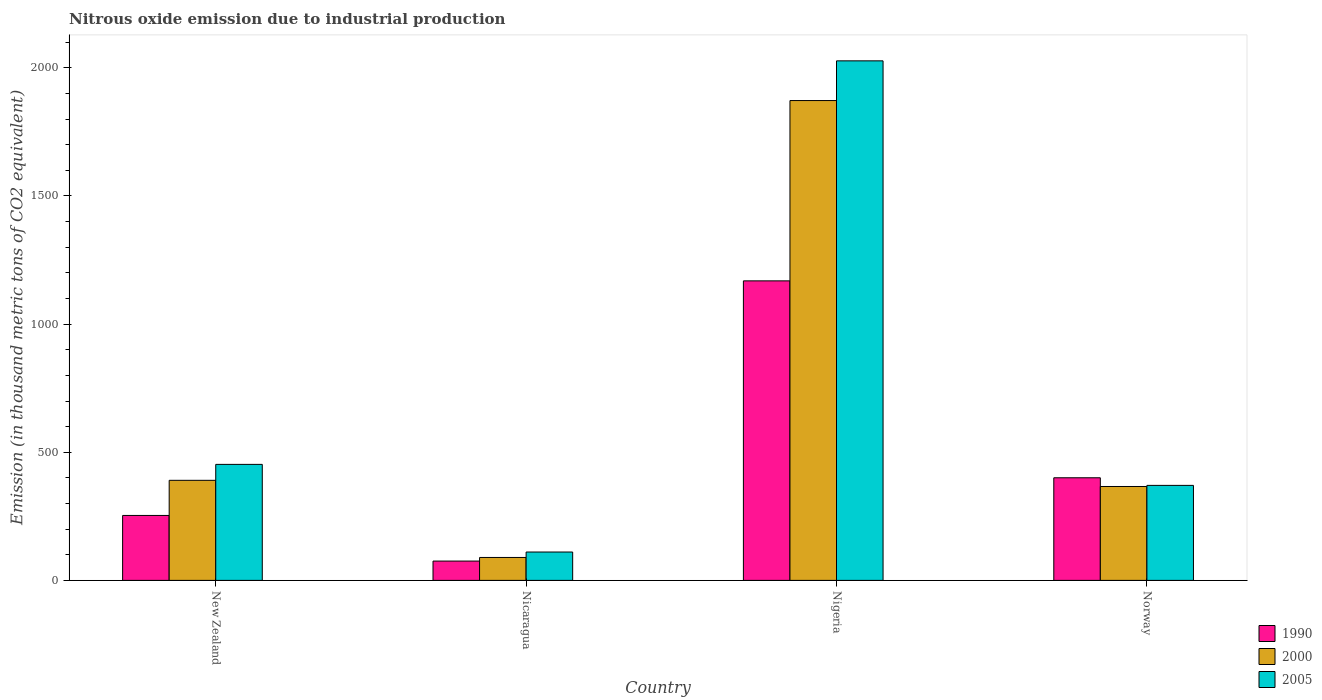Are the number of bars per tick equal to the number of legend labels?
Ensure brevity in your answer.  Yes. Are the number of bars on each tick of the X-axis equal?
Keep it short and to the point. Yes. How many bars are there on the 1st tick from the left?
Provide a short and direct response. 3. How many bars are there on the 3rd tick from the right?
Your response must be concise. 3. What is the label of the 3rd group of bars from the left?
Make the answer very short. Nigeria. In how many cases, is the number of bars for a given country not equal to the number of legend labels?
Your answer should be compact. 0. What is the amount of nitrous oxide emitted in 2005 in New Zealand?
Provide a succinct answer. 452.7. Across all countries, what is the maximum amount of nitrous oxide emitted in 2005?
Give a very brief answer. 2027.3. Across all countries, what is the minimum amount of nitrous oxide emitted in 2005?
Provide a short and direct response. 110.7. In which country was the amount of nitrous oxide emitted in 1990 maximum?
Your answer should be compact. Nigeria. In which country was the amount of nitrous oxide emitted in 1990 minimum?
Provide a succinct answer. Nicaragua. What is the total amount of nitrous oxide emitted in 2000 in the graph?
Give a very brief answer. 2718.8. What is the difference between the amount of nitrous oxide emitted in 2005 in Nicaragua and that in Norway?
Your response must be concise. -260. What is the difference between the amount of nitrous oxide emitted in 2005 in Nigeria and the amount of nitrous oxide emitted in 2000 in Norway?
Ensure brevity in your answer.  1660.9. What is the average amount of nitrous oxide emitted in 2000 per country?
Make the answer very short. 679.7. What is the difference between the amount of nitrous oxide emitted of/in 2005 and amount of nitrous oxide emitted of/in 1990 in New Zealand?
Give a very brief answer. 199.3. What is the ratio of the amount of nitrous oxide emitted in 1990 in Nicaragua to that in Norway?
Your answer should be very brief. 0.19. Is the amount of nitrous oxide emitted in 2000 in Nicaragua less than that in Nigeria?
Keep it short and to the point. Yes. What is the difference between the highest and the second highest amount of nitrous oxide emitted in 1990?
Make the answer very short. 915.4. What is the difference between the highest and the lowest amount of nitrous oxide emitted in 1990?
Make the answer very short. 1093.4. In how many countries, is the amount of nitrous oxide emitted in 2000 greater than the average amount of nitrous oxide emitted in 2000 taken over all countries?
Give a very brief answer. 1. Is the sum of the amount of nitrous oxide emitted in 2005 in Nicaragua and Norway greater than the maximum amount of nitrous oxide emitted in 1990 across all countries?
Offer a very short reply. No. What does the 1st bar from the left in Nigeria represents?
Provide a succinct answer. 1990. Is it the case that in every country, the sum of the amount of nitrous oxide emitted in 2005 and amount of nitrous oxide emitted in 2000 is greater than the amount of nitrous oxide emitted in 1990?
Offer a very short reply. Yes. How many bars are there?
Make the answer very short. 12. Are all the bars in the graph horizontal?
Your answer should be compact. No. What is the difference between two consecutive major ticks on the Y-axis?
Offer a very short reply. 500. Does the graph contain grids?
Make the answer very short. No. Where does the legend appear in the graph?
Ensure brevity in your answer.  Bottom right. How many legend labels are there?
Your answer should be compact. 3. How are the legend labels stacked?
Your response must be concise. Vertical. What is the title of the graph?
Your answer should be very brief. Nitrous oxide emission due to industrial production. What is the label or title of the Y-axis?
Offer a very short reply. Emission (in thousand metric tons of CO2 equivalent). What is the Emission (in thousand metric tons of CO2 equivalent) of 1990 in New Zealand?
Ensure brevity in your answer.  253.4. What is the Emission (in thousand metric tons of CO2 equivalent) in 2000 in New Zealand?
Your answer should be very brief. 390.5. What is the Emission (in thousand metric tons of CO2 equivalent) in 2005 in New Zealand?
Give a very brief answer. 452.7. What is the Emission (in thousand metric tons of CO2 equivalent) of 1990 in Nicaragua?
Make the answer very short. 75.4. What is the Emission (in thousand metric tons of CO2 equivalent) in 2000 in Nicaragua?
Your answer should be very brief. 89.5. What is the Emission (in thousand metric tons of CO2 equivalent) of 2005 in Nicaragua?
Give a very brief answer. 110.7. What is the Emission (in thousand metric tons of CO2 equivalent) of 1990 in Nigeria?
Offer a very short reply. 1168.8. What is the Emission (in thousand metric tons of CO2 equivalent) of 2000 in Nigeria?
Offer a terse response. 1872.4. What is the Emission (in thousand metric tons of CO2 equivalent) in 2005 in Nigeria?
Make the answer very short. 2027.3. What is the Emission (in thousand metric tons of CO2 equivalent) of 1990 in Norway?
Give a very brief answer. 400.4. What is the Emission (in thousand metric tons of CO2 equivalent) in 2000 in Norway?
Keep it short and to the point. 366.4. What is the Emission (in thousand metric tons of CO2 equivalent) of 2005 in Norway?
Provide a short and direct response. 370.7. Across all countries, what is the maximum Emission (in thousand metric tons of CO2 equivalent) of 1990?
Ensure brevity in your answer.  1168.8. Across all countries, what is the maximum Emission (in thousand metric tons of CO2 equivalent) of 2000?
Your answer should be compact. 1872.4. Across all countries, what is the maximum Emission (in thousand metric tons of CO2 equivalent) in 2005?
Your response must be concise. 2027.3. Across all countries, what is the minimum Emission (in thousand metric tons of CO2 equivalent) in 1990?
Ensure brevity in your answer.  75.4. Across all countries, what is the minimum Emission (in thousand metric tons of CO2 equivalent) of 2000?
Offer a very short reply. 89.5. Across all countries, what is the minimum Emission (in thousand metric tons of CO2 equivalent) in 2005?
Keep it short and to the point. 110.7. What is the total Emission (in thousand metric tons of CO2 equivalent) of 1990 in the graph?
Your answer should be compact. 1898. What is the total Emission (in thousand metric tons of CO2 equivalent) of 2000 in the graph?
Offer a very short reply. 2718.8. What is the total Emission (in thousand metric tons of CO2 equivalent) in 2005 in the graph?
Keep it short and to the point. 2961.4. What is the difference between the Emission (in thousand metric tons of CO2 equivalent) of 1990 in New Zealand and that in Nicaragua?
Offer a very short reply. 178. What is the difference between the Emission (in thousand metric tons of CO2 equivalent) of 2000 in New Zealand and that in Nicaragua?
Your answer should be compact. 301. What is the difference between the Emission (in thousand metric tons of CO2 equivalent) in 2005 in New Zealand and that in Nicaragua?
Make the answer very short. 342. What is the difference between the Emission (in thousand metric tons of CO2 equivalent) of 1990 in New Zealand and that in Nigeria?
Offer a very short reply. -915.4. What is the difference between the Emission (in thousand metric tons of CO2 equivalent) of 2000 in New Zealand and that in Nigeria?
Your answer should be compact. -1481.9. What is the difference between the Emission (in thousand metric tons of CO2 equivalent) of 2005 in New Zealand and that in Nigeria?
Your answer should be very brief. -1574.6. What is the difference between the Emission (in thousand metric tons of CO2 equivalent) of 1990 in New Zealand and that in Norway?
Your answer should be compact. -147. What is the difference between the Emission (in thousand metric tons of CO2 equivalent) of 2000 in New Zealand and that in Norway?
Your response must be concise. 24.1. What is the difference between the Emission (in thousand metric tons of CO2 equivalent) of 2005 in New Zealand and that in Norway?
Provide a short and direct response. 82. What is the difference between the Emission (in thousand metric tons of CO2 equivalent) of 1990 in Nicaragua and that in Nigeria?
Give a very brief answer. -1093.4. What is the difference between the Emission (in thousand metric tons of CO2 equivalent) of 2000 in Nicaragua and that in Nigeria?
Provide a succinct answer. -1782.9. What is the difference between the Emission (in thousand metric tons of CO2 equivalent) of 2005 in Nicaragua and that in Nigeria?
Give a very brief answer. -1916.6. What is the difference between the Emission (in thousand metric tons of CO2 equivalent) in 1990 in Nicaragua and that in Norway?
Your answer should be very brief. -325. What is the difference between the Emission (in thousand metric tons of CO2 equivalent) of 2000 in Nicaragua and that in Norway?
Ensure brevity in your answer.  -276.9. What is the difference between the Emission (in thousand metric tons of CO2 equivalent) of 2005 in Nicaragua and that in Norway?
Provide a succinct answer. -260. What is the difference between the Emission (in thousand metric tons of CO2 equivalent) in 1990 in Nigeria and that in Norway?
Ensure brevity in your answer.  768.4. What is the difference between the Emission (in thousand metric tons of CO2 equivalent) in 2000 in Nigeria and that in Norway?
Your response must be concise. 1506. What is the difference between the Emission (in thousand metric tons of CO2 equivalent) of 2005 in Nigeria and that in Norway?
Provide a short and direct response. 1656.6. What is the difference between the Emission (in thousand metric tons of CO2 equivalent) of 1990 in New Zealand and the Emission (in thousand metric tons of CO2 equivalent) of 2000 in Nicaragua?
Provide a succinct answer. 163.9. What is the difference between the Emission (in thousand metric tons of CO2 equivalent) in 1990 in New Zealand and the Emission (in thousand metric tons of CO2 equivalent) in 2005 in Nicaragua?
Make the answer very short. 142.7. What is the difference between the Emission (in thousand metric tons of CO2 equivalent) in 2000 in New Zealand and the Emission (in thousand metric tons of CO2 equivalent) in 2005 in Nicaragua?
Keep it short and to the point. 279.8. What is the difference between the Emission (in thousand metric tons of CO2 equivalent) in 1990 in New Zealand and the Emission (in thousand metric tons of CO2 equivalent) in 2000 in Nigeria?
Keep it short and to the point. -1619. What is the difference between the Emission (in thousand metric tons of CO2 equivalent) of 1990 in New Zealand and the Emission (in thousand metric tons of CO2 equivalent) of 2005 in Nigeria?
Ensure brevity in your answer.  -1773.9. What is the difference between the Emission (in thousand metric tons of CO2 equivalent) of 2000 in New Zealand and the Emission (in thousand metric tons of CO2 equivalent) of 2005 in Nigeria?
Offer a terse response. -1636.8. What is the difference between the Emission (in thousand metric tons of CO2 equivalent) of 1990 in New Zealand and the Emission (in thousand metric tons of CO2 equivalent) of 2000 in Norway?
Offer a terse response. -113. What is the difference between the Emission (in thousand metric tons of CO2 equivalent) in 1990 in New Zealand and the Emission (in thousand metric tons of CO2 equivalent) in 2005 in Norway?
Provide a succinct answer. -117.3. What is the difference between the Emission (in thousand metric tons of CO2 equivalent) in 2000 in New Zealand and the Emission (in thousand metric tons of CO2 equivalent) in 2005 in Norway?
Provide a short and direct response. 19.8. What is the difference between the Emission (in thousand metric tons of CO2 equivalent) in 1990 in Nicaragua and the Emission (in thousand metric tons of CO2 equivalent) in 2000 in Nigeria?
Make the answer very short. -1797. What is the difference between the Emission (in thousand metric tons of CO2 equivalent) in 1990 in Nicaragua and the Emission (in thousand metric tons of CO2 equivalent) in 2005 in Nigeria?
Your response must be concise. -1951.9. What is the difference between the Emission (in thousand metric tons of CO2 equivalent) in 2000 in Nicaragua and the Emission (in thousand metric tons of CO2 equivalent) in 2005 in Nigeria?
Ensure brevity in your answer.  -1937.8. What is the difference between the Emission (in thousand metric tons of CO2 equivalent) of 1990 in Nicaragua and the Emission (in thousand metric tons of CO2 equivalent) of 2000 in Norway?
Your answer should be compact. -291. What is the difference between the Emission (in thousand metric tons of CO2 equivalent) of 1990 in Nicaragua and the Emission (in thousand metric tons of CO2 equivalent) of 2005 in Norway?
Ensure brevity in your answer.  -295.3. What is the difference between the Emission (in thousand metric tons of CO2 equivalent) of 2000 in Nicaragua and the Emission (in thousand metric tons of CO2 equivalent) of 2005 in Norway?
Offer a very short reply. -281.2. What is the difference between the Emission (in thousand metric tons of CO2 equivalent) of 1990 in Nigeria and the Emission (in thousand metric tons of CO2 equivalent) of 2000 in Norway?
Offer a terse response. 802.4. What is the difference between the Emission (in thousand metric tons of CO2 equivalent) in 1990 in Nigeria and the Emission (in thousand metric tons of CO2 equivalent) in 2005 in Norway?
Make the answer very short. 798.1. What is the difference between the Emission (in thousand metric tons of CO2 equivalent) of 2000 in Nigeria and the Emission (in thousand metric tons of CO2 equivalent) of 2005 in Norway?
Your answer should be compact. 1501.7. What is the average Emission (in thousand metric tons of CO2 equivalent) of 1990 per country?
Offer a terse response. 474.5. What is the average Emission (in thousand metric tons of CO2 equivalent) of 2000 per country?
Offer a very short reply. 679.7. What is the average Emission (in thousand metric tons of CO2 equivalent) in 2005 per country?
Offer a terse response. 740.35. What is the difference between the Emission (in thousand metric tons of CO2 equivalent) of 1990 and Emission (in thousand metric tons of CO2 equivalent) of 2000 in New Zealand?
Give a very brief answer. -137.1. What is the difference between the Emission (in thousand metric tons of CO2 equivalent) in 1990 and Emission (in thousand metric tons of CO2 equivalent) in 2005 in New Zealand?
Ensure brevity in your answer.  -199.3. What is the difference between the Emission (in thousand metric tons of CO2 equivalent) in 2000 and Emission (in thousand metric tons of CO2 equivalent) in 2005 in New Zealand?
Ensure brevity in your answer.  -62.2. What is the difference between the Emission (in thousand metric tons of CO2 equivalent) in 1990 and Emission (in thousand metric tons of CO2 equivalent) in 2000 in Nicaragua?
Make the answer very short. -14.1. What is the difference between the Emission (in thousand metric tons of CO2 equivalent) in 1990 and Emission (in thousand metric tons of CO2 equivalent) in 2005 in Nicaragua?
Ensure brevity in your answer.  -35.3. What is the difference between the Emission (in thousand metric tons of CO2 equivalent) of 2000 and Emission (in thousand metric tons of CO2 equivalent) of 2005 in Nicaragua?
Keep it short and to the point. -21.2. What is the difference between the Emission (in thousand metric tons of CO2 equivalent) in 1990 and Emission (in thousand metric tons of CO2 equivalent) in 2000 in Nigeria?
Your answer should be very brief. -703.6. What is the difference between the Emission (in thousand metric tons of CO2 equivalent) of 1990 and Emission (in thousand metric tons of CO2 equivalent) of 2005 in Nigeria?
Your answer should be very brief. -858.5. What is the difference between the Emission (in thousand metric tons of CO2 equivalent) in 2000 and Emission (in thousand metric tons of CO2 equivalent) in 2005 in Nigeria?
Offer a terse response. -154.9. What is the difference between the Emission (in thousand metric tons of CO2 equivalent) of 1990 and Emission (in thousand metric tons of CO2 equivalent) of 2005 in Norway?
Your response must be concise. 29.7. What is the ratio of the Emission (in thousand metric tons of CO2 equivalent) in 1990 in New Zealand to that in Nicaragua?
Offer a very short reply. 3.36. What is the ratio of the Emission (in thousand metric tons of CO2 equivalent) in 2000 in New Zealand to that in Nicaragua?
Your answer should be very brief. 4.36. What is the ratio of the Emission (in thousand metric tons of CO2 equivalent) in 2005 in New Zealand to that in Nicaragua?
Ensure brevity in your answer.  4.09. What is the ratio of the Emission (in thousand metric tons of CO2 equivalent) of 1990 in New Zealand to that in Nigeria?
Ensure brevity in your answer.  0.22. What is the ratio of the Emission (in thousand metric tons of CO2 equivalent) in 2000 in New Zealand to that in Nigeria?
Keep it short and to the point. 0.21. What is the ratio of the Emission (in thousand metric tons of CO2 equivalent) of 2005 in New Zealand to that in Nigeria?
Your answer should be compact. 0.22. What is the ratio of the Emission (in thousand metric tons of CO2 equivalent) in 1990 in New Zealand to that in Norway?
Provide a short and direct response. 0.63. What is the ratio of the Emission (in thousand metric tons of CO2 equivalent) of 2000 in New Zealand to that in Norway?
Ensure brevity in your answer.  1.07. What is the ratio of the Emission (in thousand metric tons of CO2 equivalent) of 2005 in New Zealand to that in Norway?
Provide a short and direct response. 1.22. What is the ratio of the Emission (in thousand metric tons of CO2 equivalent) in 1990 in Nicaragua to that in Nigeria?
Your response must be concise. 0.06. What is the ratio of the Emission (in thousand metric tons of CO2 equivalent) in 2000 in Nicaragua to that in Nigeria?
Provide a short and direct response. 0.05. What is the ratio of the Emission (in thousand metric tons of CO2 equivalent) of 2005 in Nicaragua to that in Nigeria?
Your answer should be very brief. 0.05. What is the ratio of the Emission (in thousand metric tons of CO2 equivalent) in 1990 in Nicaragua to that in Norway?
Give a very brief answer. 0.19. What is the ratio of the Emission (in thousand metric tons of CO2 equivalent) in 2000 in Nicaragua to that in Norway?
Provide a succinct answer. 0.24. What is the ratio of the Emission (in thousand metric tons of CO2 equivalent) of 2005 in Nicaragua to that in Norway?
Your response must be concise. 0.3. What is the ratio of the Emission (in thousand metric tons of CO2 equivalent) of 1990 in Nigeria to that in Norway?
Provide a succinct answer. 2.92. What is the ratio of the Emission (in thousand metric tons of CO2 equivalent) of 2000 in Nigeria to that in Norway?
Ensure brevity in your answer.  5.11. What is the ratio of the Emission (in thousand metric tons of CO2 equivalent) of 2005 in Nigeria to that in Norway?
Keep it short and to the point. 5.47. What is the difference between the highest and the second highest Emission (in thousand metric tons of CO2 equivalent) in 1990?
Provide a short and direct response. 768.4. What is the difference between the highest and the second highest Emission (in thousand metric tons of CO2 equivalent) in 2000?
Your answer should be compact. 1481.9. What is the difference between the highest and the second highest Emission (in thousand metric tons of CO2 equivalent) of 2005?
Your answer should be very brief. 1574.6. What is the difference between the highest and the lowest Emission (in thousand metric tons of CO2 equivalent) of 1990?
Your answer should be compact. 1093.4. What is the difference between the highest and the lowest Emission (in thousand metric tons of CO2 equivalent) of 2000?
Offer a terse response. 1782.9. What is the difference between the highest and the lowest Emission (in thousand metric tons of CO2 equivalent) of 2005?
Ensure brevity in your answer.  1916.6. 